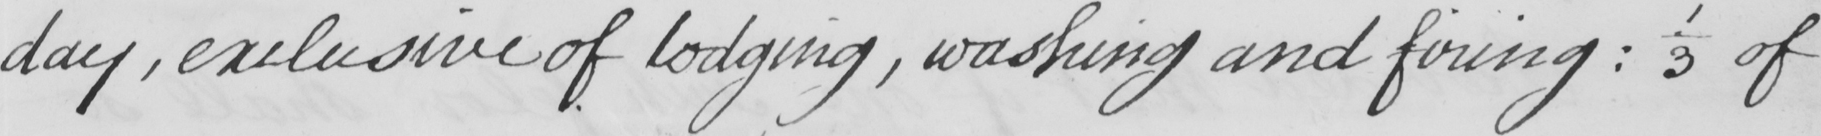Please provide the text content of this handwritten line. day , exclusive of lodging , washing and firing  :  1/3 of 